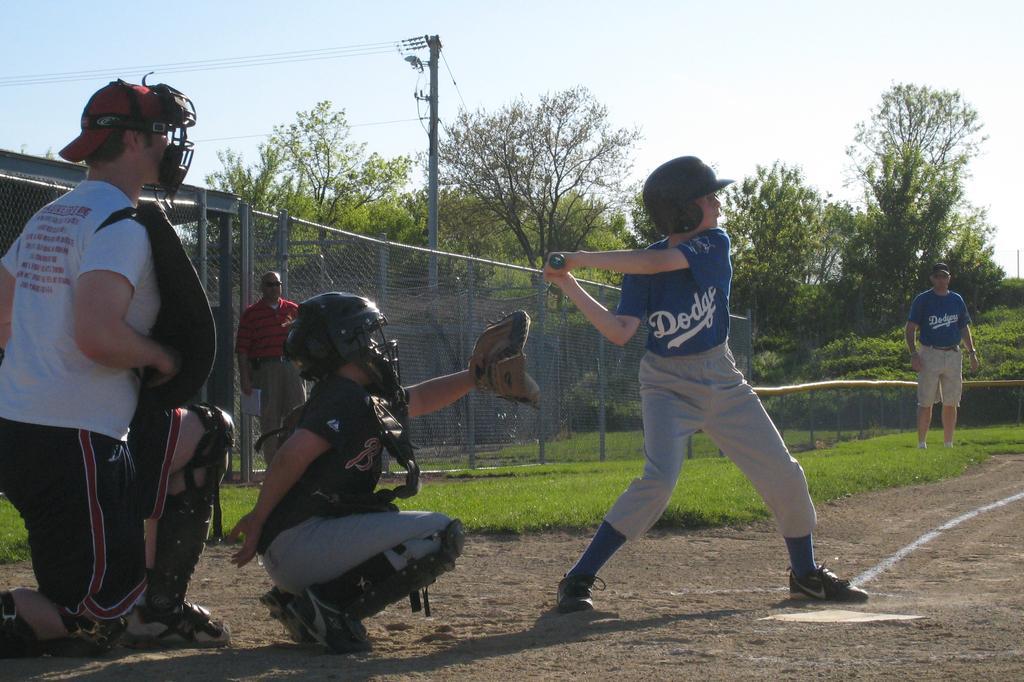Could you give a brief overview of what you see in this image? In this picture there is a small boy wearing blue t- shirt, grey pant and playing the baseball game. Behind there is a another sitting on the ground wearing black helmet and trying to catch the ball. Behind there is a fencing grill and some trees. In the background there is a electric pole and cables. 